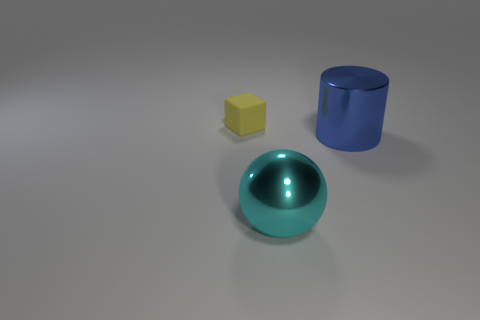What textures are visible on the objects in the image? The large cyan sphere has a smooth and shiny texture, reflecting light and showing highlights. The yellow block appears to have a more matte or subdued finish, diffusing light softly, without reflections. The cylinder is also shiny, but less reflective than the cyan sphere, indicating possibly a different material or less gloss. 